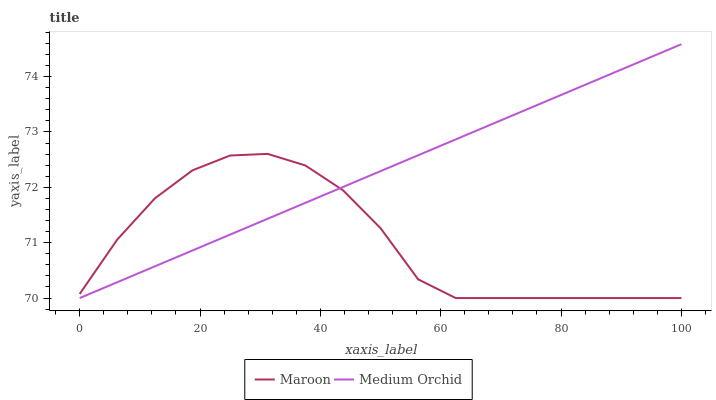Does Maroon have the maximum area under the curve?
Answer yes or no. No. Is Maroon the smoothest?
Answer yes or no. No. Does Maroon have the highest value?
Answer yes or no. No. 